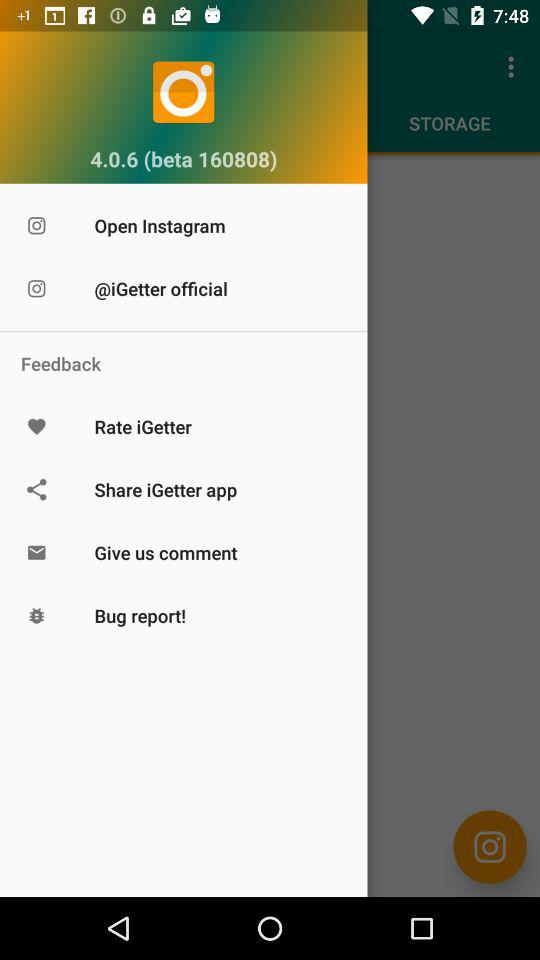What is the version? The version is 4.0.6 (beta 160808). 